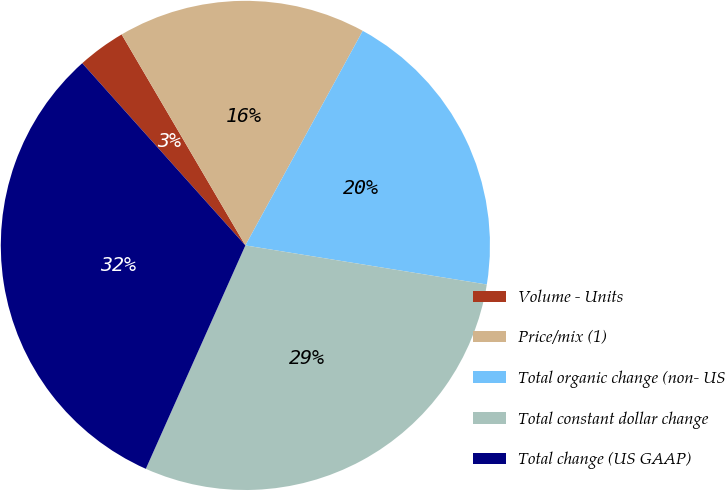<chart> <loc_0><loc_0><loc_500><loc_500><pie_chart><fcel>Volume - Units<fcel>Price/mix (1)<fcel>Total organic change (non- US<fcel>Total constant dollar change<fcel>Total change (US GAAP)<nl><fcel>3.18%<fcel>16.41%<fcel>19.59%<fcel>29.12%<fcel>31.71%<nl></chart> 